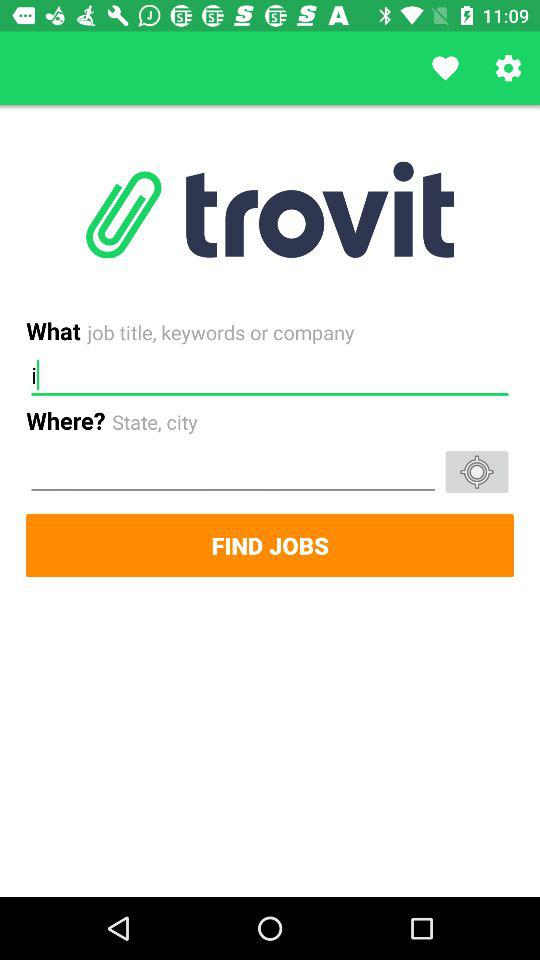What is the name of the user? The name of the user is Grace Chan. 